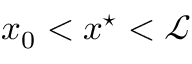<formula> <loc_0><loc_0><loc_500><loc_500>x _ { 0 } < x ^ { ^ { * } } < \mathcal { L }</formula> 